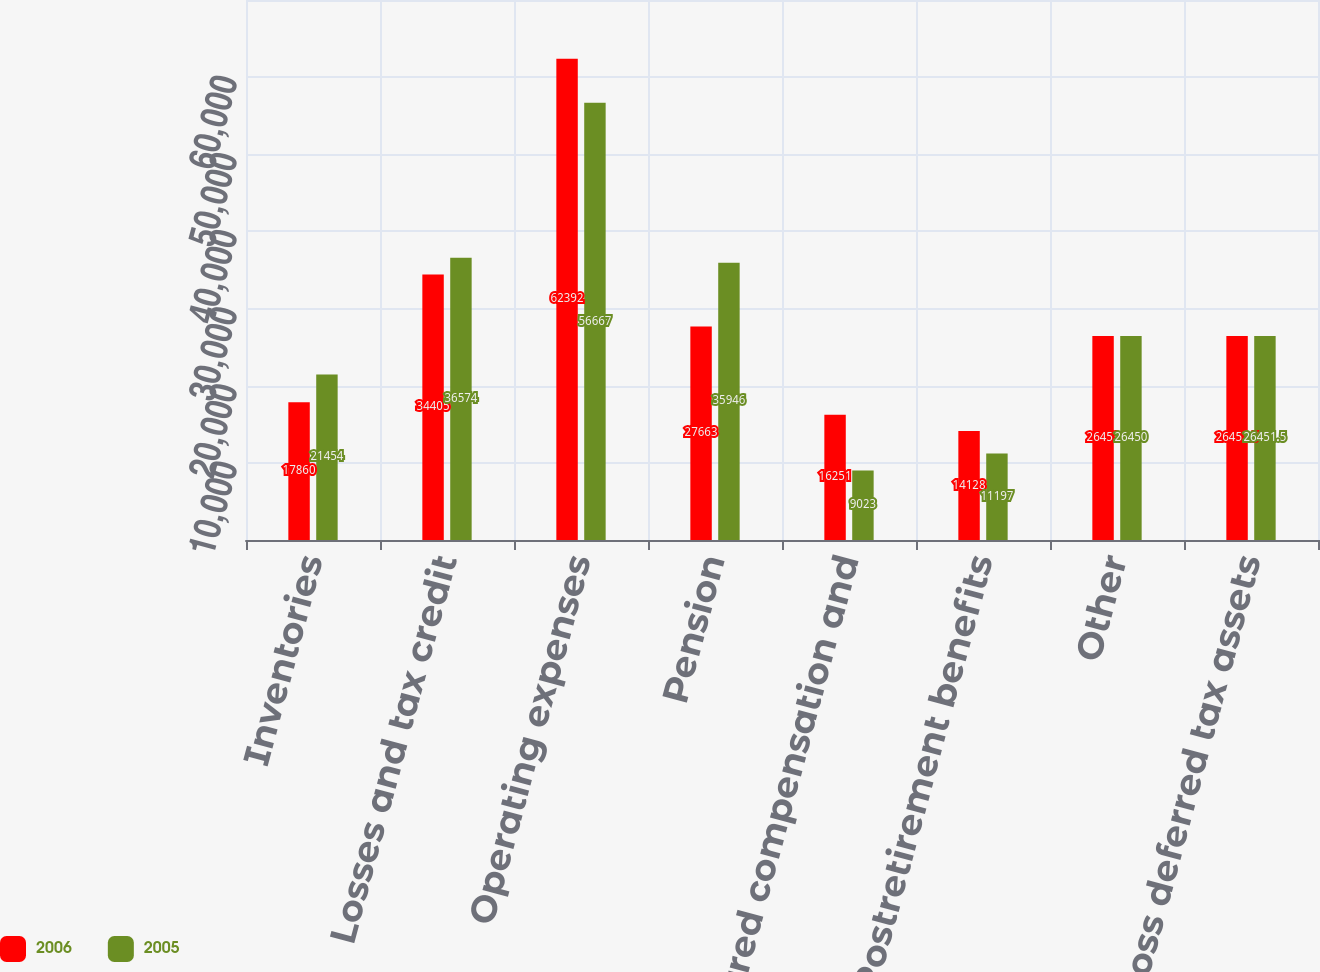<chart> <loc_0><loc_0><loc_500><loc_500><stacked_bar_chart><ecel><fcel>Inventories<fcel>Losses and tax credit<fcel>Operating expenses<fcel>Pension<fcel>Deferred compensation and<fcel>Postretirement benefits<fcel>Other<fcel>Gross deferred tax assets<nl><fcel>2006<fcel>17860<fcel>34405<fcel>62392<fcel>27663<fcel>16251<fcel>14128<fcel>26453<fcel>26451.5<nl><fcel>2005<fcel>21454<fcel>36574<fcel>56667<fcel>35946<fcel>9023<fcel>11197<fcel>26450<fcel>26451.5<nl></chart> 